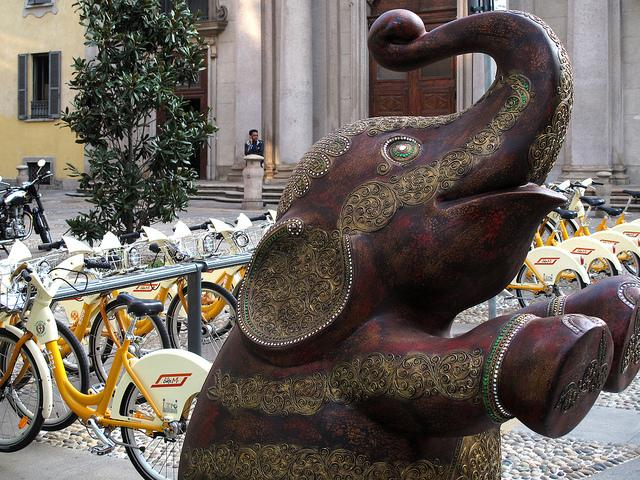Why are all the bikes the same? rentals 